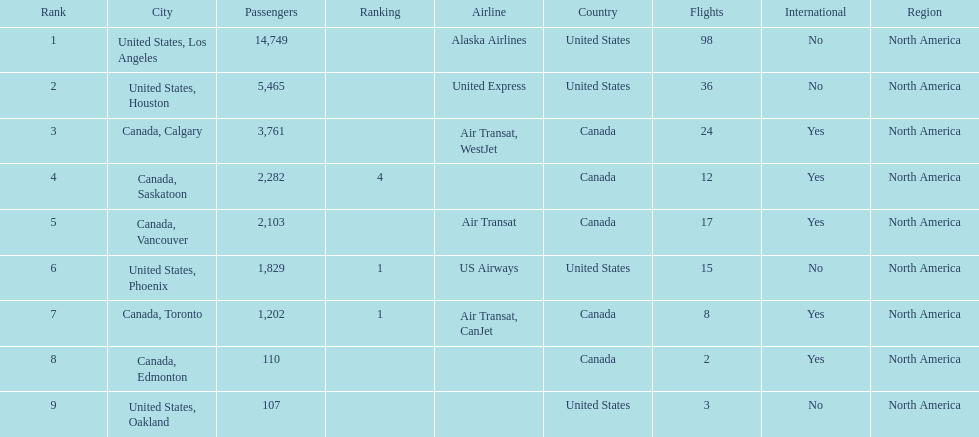How many cities from canada are on this list? 5. 